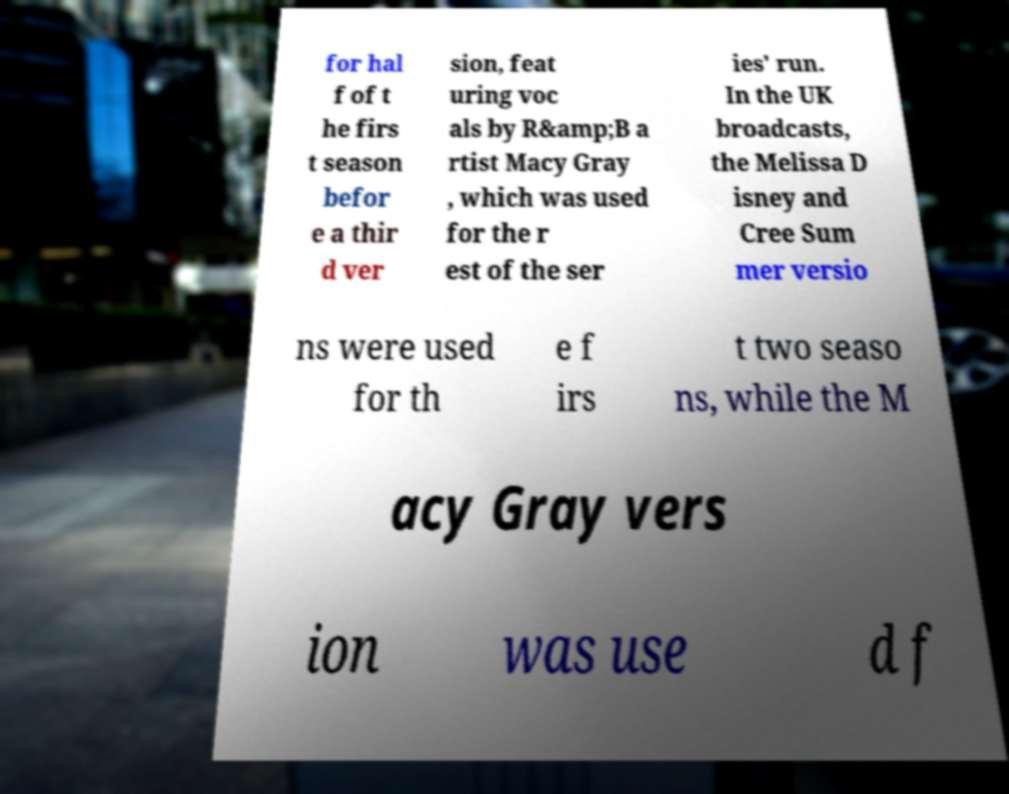Can you accurately transcribe the text from the provided image for me? for hal f of t he firs t season befor e a thir d ver sion, feat uring voc als by R&amp;B a rtist Macy Gray , which was used for the r est of the ser ies' run. In the UK broadcasts, the Melissa D isney and Cree Sum mer versio ns were used for th e f irs t two seaso ns, while the M acy Gray vers ion was use d f 